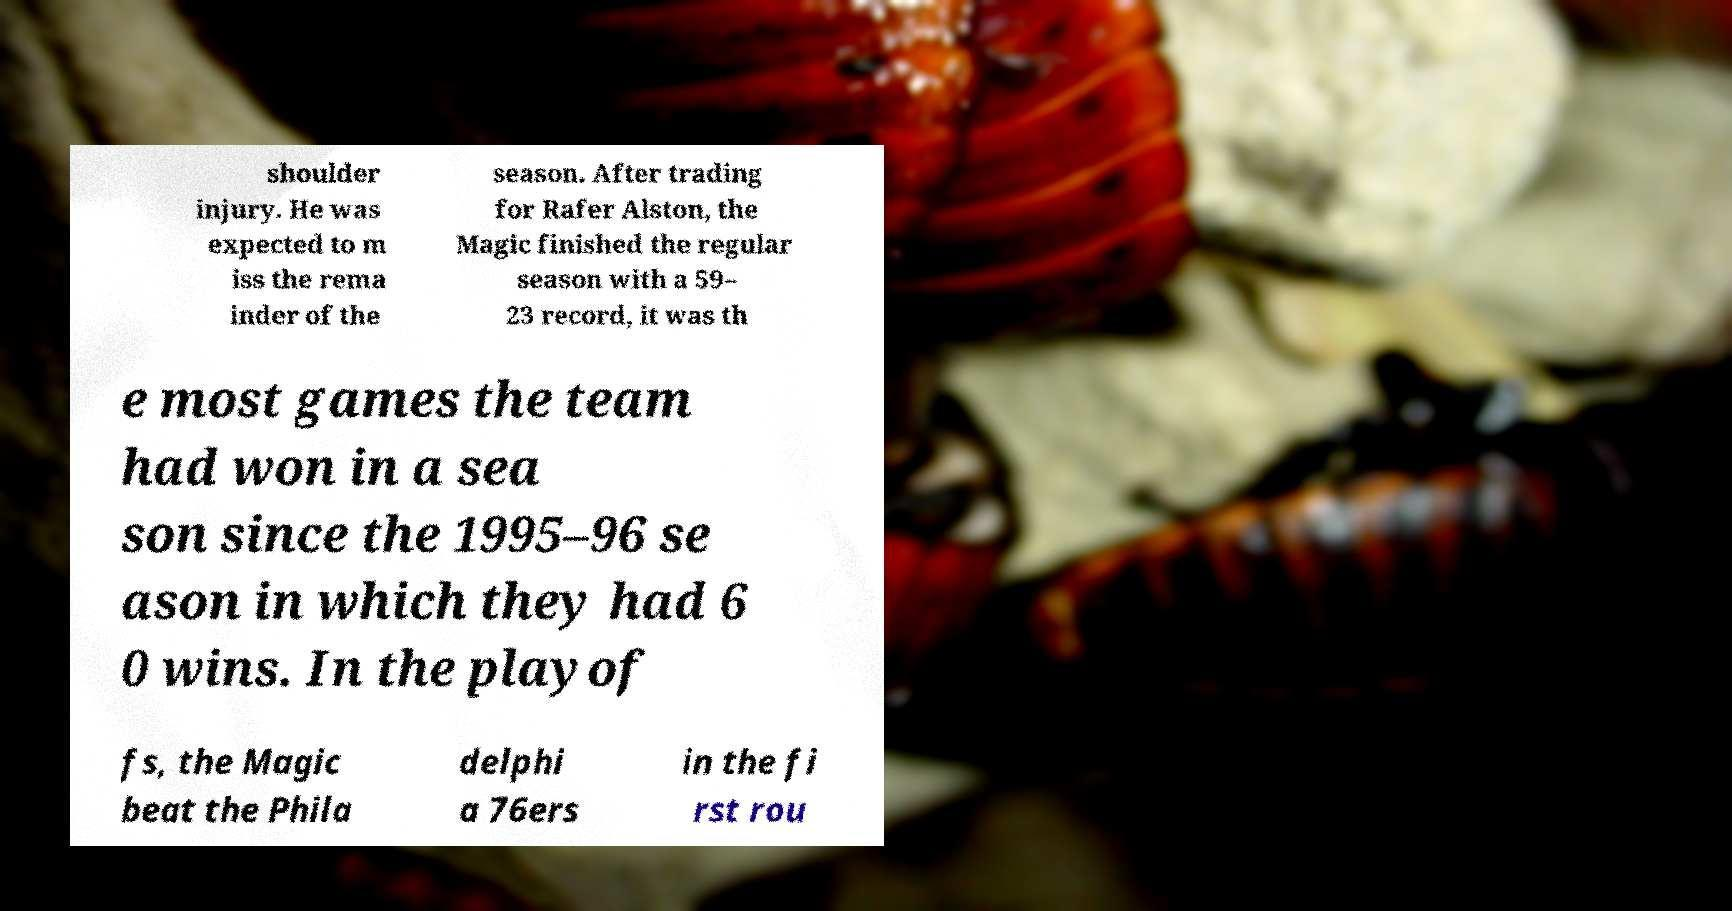There's text embedded in this image that I need extracted. Can you transcribe it verbatim? shoulder injury. He was expected to m iss the rema inder of the season. After trading for Rafer Alston, the Magic finished the regular season with a 59– 23 record, it was th e most games the team had won in a sea son since the 1995–96 se ason in which they had 6 0 wins. In the playof fs, the Magic beat the Phila delphi a 76ers in the fi rst rou 